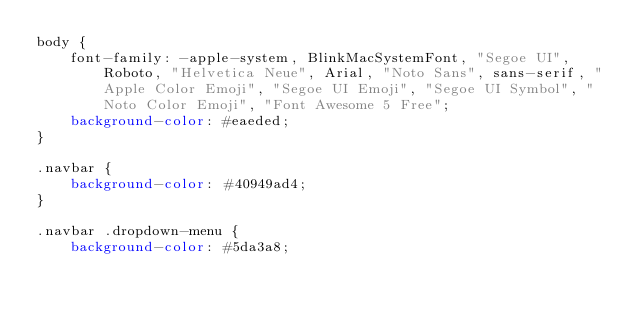<code> <loc_0><loc_0><loc_500><loc_500><_CSS_>body {
    font-family: -apple-system, BlinkMacSystemFont, "Segoe UI", Roboto, "Helvetica Neue", Arial, "Noto Sans", sans-serif, "Apple Color Emoji", "Segoe UI Emoji", "Segoe UI Symbol", "Noto Color Emoji", "Font Awesome 5 Free";
    background-color: #eaeded;
}

.navbar {
    background-color: #40949ad4;
}

.navbar .dropdown-menu {
    background-color: #5da3a8;</code> 